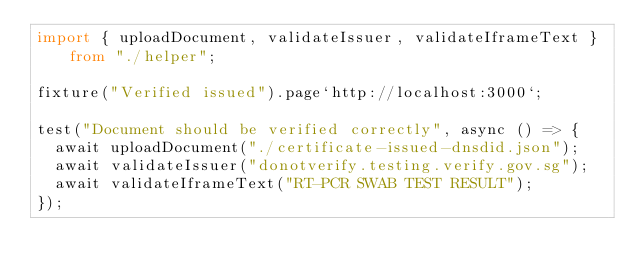Convert code to text. <code><loc_0><loc_0><loc_500><loc_500><_TypeScript_>import { uploadDocument, validateIssuer, validateIframeText } from "./helper";

fixture("Verified issued").page`http://localhost:3000`;

test("Document should be verified correctly", async () => {
  await uploadDocument("./certificate-issued-dnsdid.json");
  await validateIssuer("donotverify.testing.verify.gov.sg");
  await validateIframeText("RT-PCR SWAB TEST RESULT");
});
</code> 